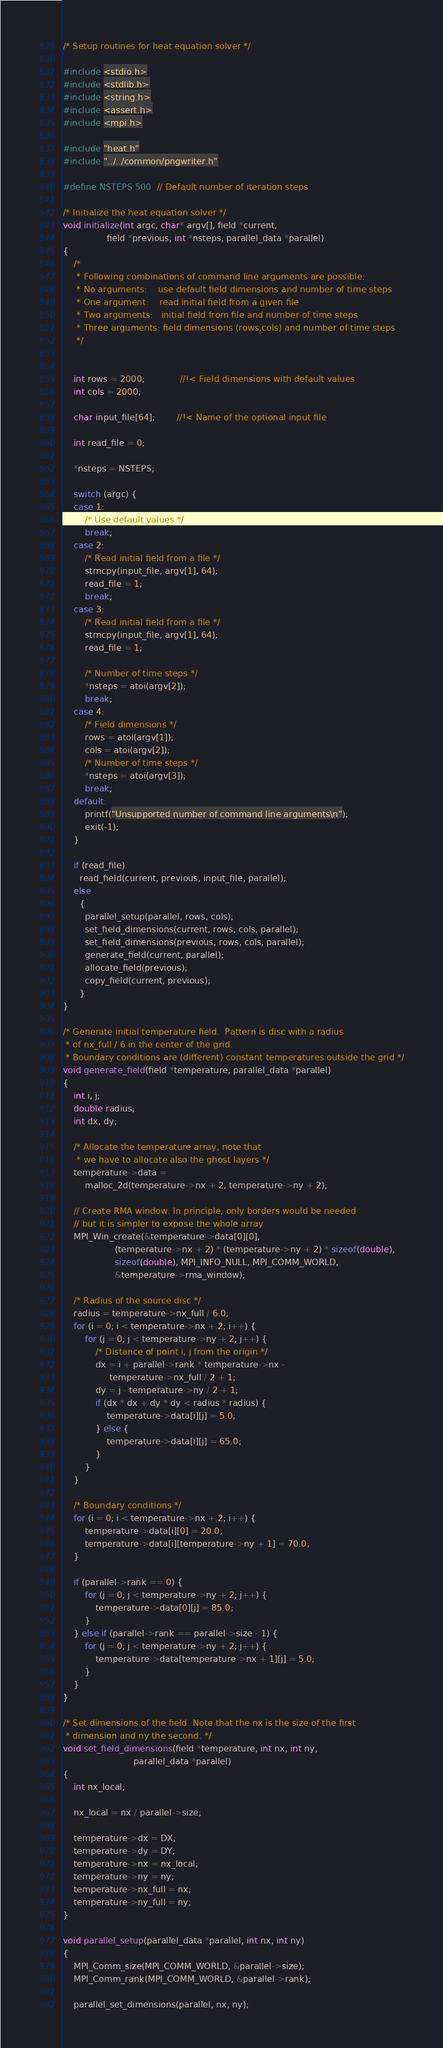Convert code to text. <code><loc_0><loc_0><loc_500><loc_500><_C_>/* Setup routines for heat equation solver */

#include <stdio.h>
#include <stdlib.h>
#include <string.h>
#include <assert.h>
#include <mpi.h>

#include "heat.h"
#include "../../common/pngwriter.h"

#define NSTEPS 500  // Default number of iteration steps

/* Initialize the heat equation solver */
void initialize(int argc, char* argv[], field *current,
                field *previous, int *nsteps, parallel_data *parallel)
{
    /*
     * Following combinations of command line arguments are possible:
     * No arguments:    use default field dimensions and number of time steps
     * One argument:    read initial field from a given file
     * Two arguments:   initial field from file and number of time steps
     * Three arguments: field dimensions (rows,cols) and number of time steps
     */


    int rows = 2000;             //!< Field dimensions with default values
    int cols = 2000;

    char input_file[64];        //!< Name of the optional input file

    int read_file = 0;

    *nsteps = NSTEPS;

    switch (argc) {
    case 1:
        /* Use default values */
        break;
    case 2:
        /* Read initial field from a file */
        strncpy(input_file, argv[1], 64);
        read_file = 1;
        break;
    case 3:
        /* Read initial field from a file */
        strncpy(input_file, argv[1], 64);
        read_file = 1;

        /* Number of time steps */
        *nsteps = atoi(argv[2]);
        break;
    case 4:
        /* Field dimensions */
        rows = atoi(argv[1]);
        cols = atoi(argv[2]);
        /* Number of time steps */
        *nsteps = atoi(argv[3]);
        break;
    default:
        printf("Unsupported number of command line arguments\n");
        exit(-1);
    }

    if (read_file)
      read_field(current, previous, input_file, parallel);
    else
      {
        parallel_setup(parallel, rows, cols);
        set_field_dimensions(current, rows, cols, parallel);
        set_field_dimensions(previous, rows, cols, parallel);
        generate_field(current, parallel);
        allocate_field(previous);
        copy_field(current, previous);
      }
}

/* Generate initial temperature field.  Pattern is disc with a radius
 * of nx_full / 6 in the center of the grid.
 * Boundary conditions are (different) constant temperatures outside the grid */
void generate_field(field *temperature, parallel_data *parallel)
{
    int i, j;
    double radius;
    int dx, dy;

    /* Allocate the temperature array, note that
     * we have to allocate also the ghost layers */
    temperature->data =
        malloc_2d(temperature->nx + 2, temperature->ny + 2);

    // Create RMA window. In principle, only borders would be needed
    // but it is simpler to expose the whole array
    MPI_Win_create(&temperature->data[0][0],
                   (temperature->nx + 2) * (temperature->ny + 2) * sizeof(double), 
                   sizeof(double), MPI_INFO_NULL, MPI_COMM_WORLD,
                   &temperature->rma_window);

    /* Radius of the source disc */
    radius = temperature->nx_full / 6.0;
    for (i = 0; i < temperature->nx + 2; i++) {
        for (j = 0; j < temperature->ny + 2; j++) {
            /* Distance of point i, j from the origin */
            dx = i + parallel->rank * temperature->nx -
                 temperature->nx_full / 2 + 1;
            dy = j - temperature->ny / 2 + 1;
            if (dx * dx + dy * dy < radius * radius) {
                temperature->data[i][j] = 5.0;
            } else {
                temperature->data[i][j] = 65.0;
            }
        }
    }

    /* Boundary conditions */
    for (i = 0; i < temperature->nx + 2; i++) {
        temperature->data[i][0] = 20.0;
        temperature->data[i][temperature->ny + 1] = 70.0;
    }

    if (parallel->rank == 0) {
        for (j = 0; j < temperature->ny + 2; j++) {
            temperature->data[0][j] = 85.0;
        }
    } else if (parallel->rank == parallel->size - 1) {
        for (j = 0; j < temperature->ny + 2; j++) {
            temperature->data[temperature->nx + 1][j] = 5.0;
        }
    }
}

/* Set dimensions of the field. Note that the nx is the size of the first
 * dimension and ny the second. */
void set_field_dimensions(field *temperature, int nx, int ny,
                          parallel_data *parallel)
{
    int nx_local;

    nx_local = nx / parallel->size;

    temperature->dx = DX;
    temperature->dy = DY;
    temperature->nx = nx_local;
    temperature->ny = ny;
    temperature->nx_full = nx;
    temperature->ny_full = ny;
}

void parallel_setup(parallel_data *parallel, int nx, int ny)
{
    MPI_Comm_size(MPI_COMM_WORLD, &parallel->size);
    MPI_Comm_rank(MPI_COMM_WORLD, &parallel->rank);

    parallel_set_dimensions(parallel, nx, ny);
</code> 